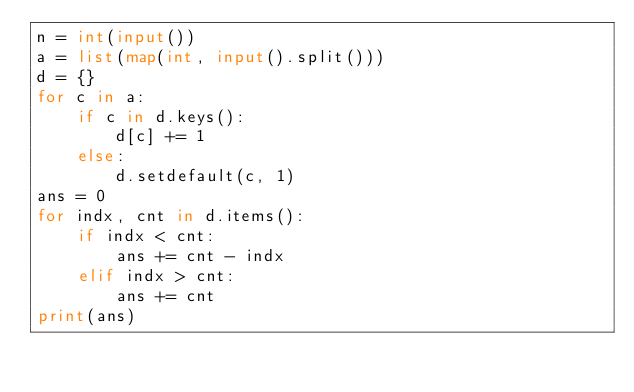Convert code to text. <code><loc_0><loc_0><loc_500><loc_500><_Python_>n = int(input())
a = list(map(int, input().split()))
d = {}
for c in a:
    if c in d.keys():
        d[c] += 1
    else:
        d.setdefault(c, 1)
ans = 0
for indx, cnt in d.items():
    if indx < cnt:
        ans += cnt - indx
    elif indx > cnt:
        ans += cnt
print(ans)</code> 